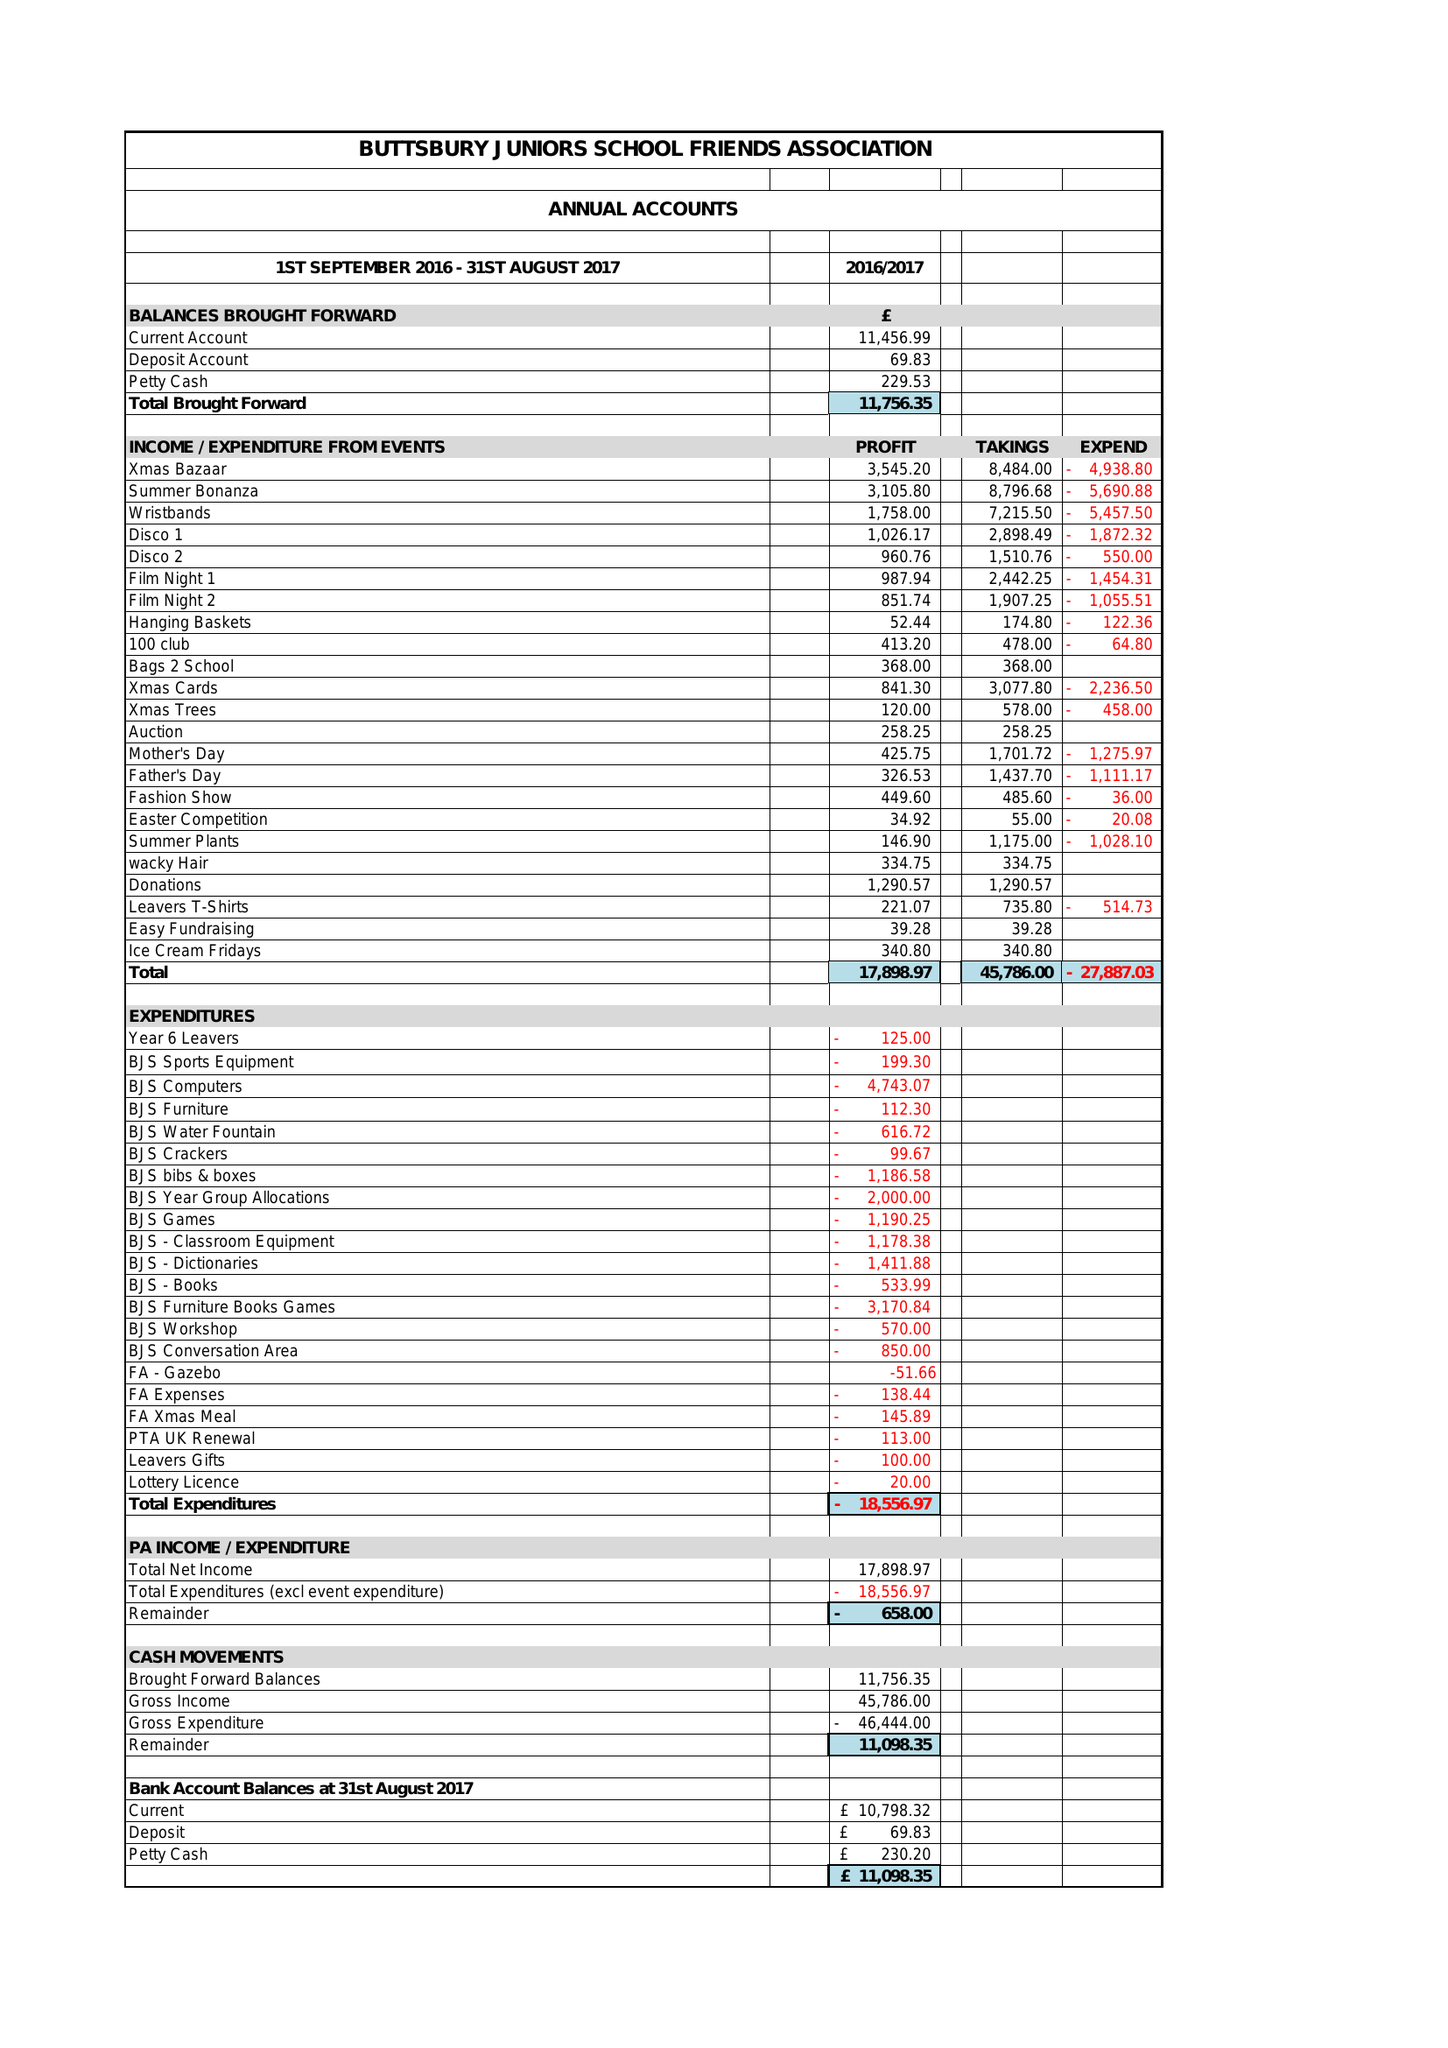What is the value for the address__street_line?
Answer the question using a single word or phrase. 23 OAKWOOD DRIVE 